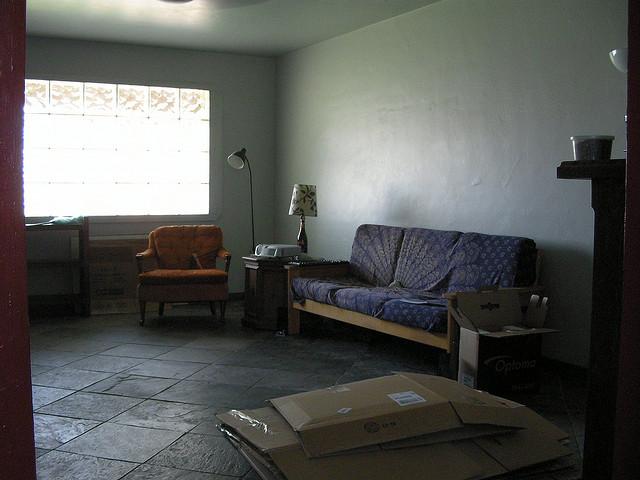Are all the lights in the photo on?
Give a very brief answer. No. Where is the light?
Answer briefly. Outside. What color is the sofa?
Keep it brief. Blue. What is present?
Be succinct. Couch, lamp, chair, boxes. What color is the couch on the right?
Keep it brief. Blue. What color is the couch?
Keep it brief. Blue. What room is this?
Short answer required. Living room. Is the lamp on?
Answer briefly. No. How many pillows in the chair on the right?
Keep it brief. 0. Are the colors in this room vivid?
Quick response, please. No. What is this room used for?
Keep it brief. Relaxing. 